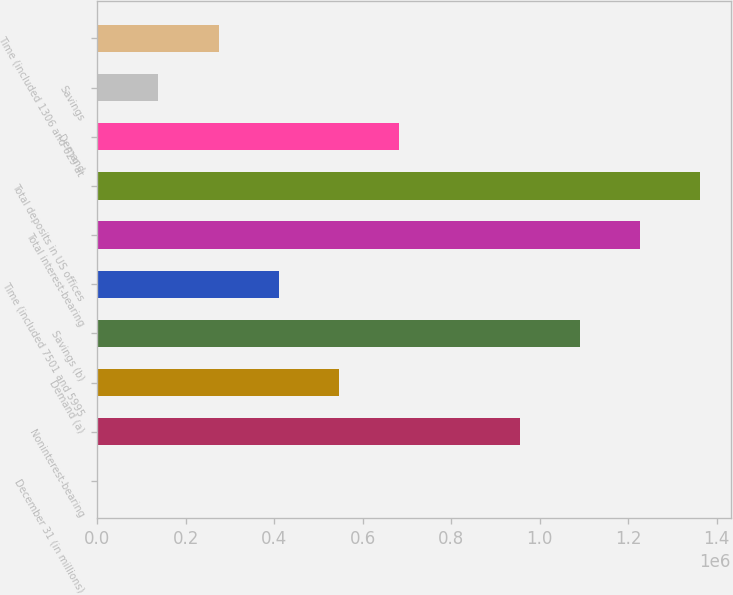Convert chart to OTSL. <chart><loc_0><loc_0><loc_500><loc_500><bar_chart><fcel>December 31 (in millions)<fcel>Noninterest-bearing<fcel>Demand (a)<fcel>Savings (b)<fcel>Time (included 7501 and 5995<fcel>Total interest-bearing<fcel>Total deposits in US offices<fcel>Demand<fcel>Savings<fcel>Time (included 1306 and 629 at<nl><fcel>2014<fcel>955003<fcel>546579<fcel>1.09114e+06<fcel>410438<fcel>1.22729e+06<fcel>1.36343e+06<fcel>682720<fcel>138155<fcel>274297<nl></chart> 